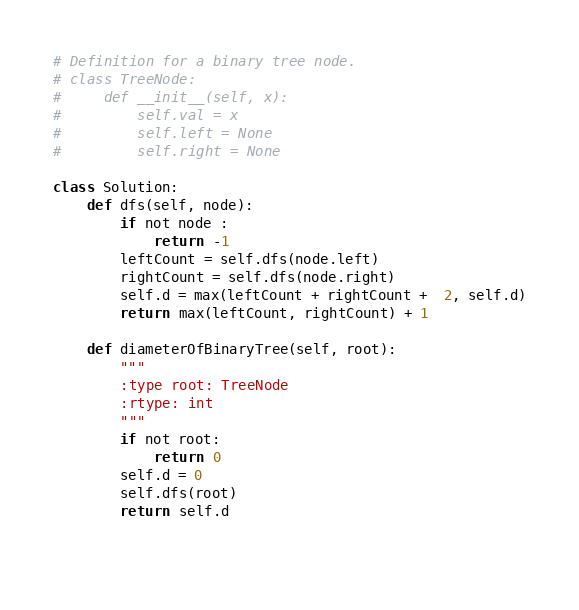<code> <loc_0><loc_0><loc_500><loc_500><_Python_># Definition for a binary tree node.
# class TreeNode:
#     def __init__(self, x):
#         self.val = x
#         self.left = None
#         self.right = None
 
class Solution:
    def dfs(self, node):
        if not node :
            return -1
        leftCount = self.dfs(node.left)
        rightCount = self.dfs(node.right)
        self.d = max(leftCount + rightCount +  2, self.d)
        return max(leftCount, rightCount) + 1
    
    def diameterOfBinaryTree(self, root):
        """
        :type root: TreeNode
        :rtype: int
        """
        if not root:
            return 0
        self.d = 0
        self.dfs(root)
        return self.d
                     
    </code> 